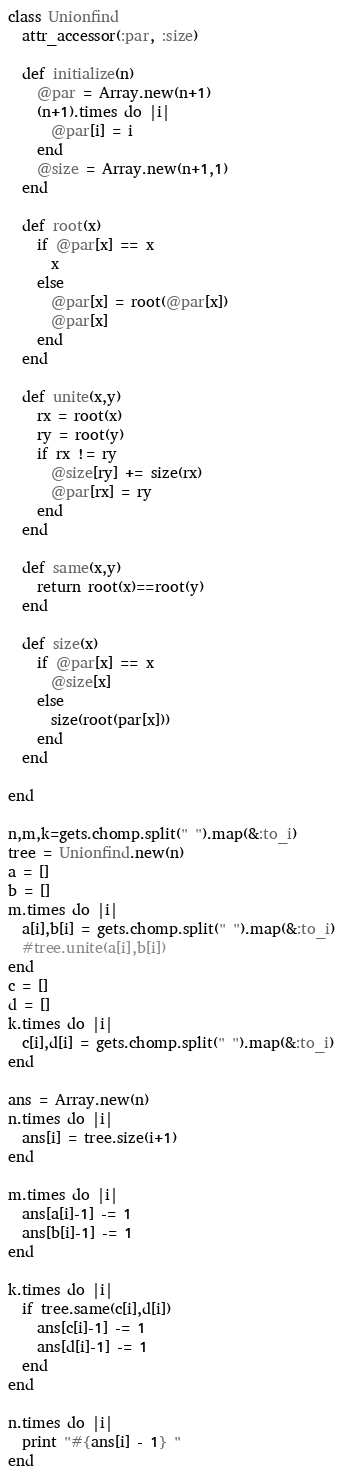Convert code to text. <code><loc_0><loc_0><loc_500><loc_500><_Ruby_>class Unionfind
  attr_accessor(:par, :size)

  def initialize(n)
    @par = Array.new(n+1)
    (n+1).times do |i|
      @par[i] = i
    end
    @size = Array.new(n+1,1)
  end

  def root(x)
    if @par[x] == x
      x
    else
      @par[x] = root(@par[x])
      @par[x]
    end
  end

  def unite(x,y)
    rx = root(x)
    ry = root(y)
    if rx != ry
      @size[ry] += size(rx)
      @par[rx] = ry
    end
  end

  def same(x,y)
    return root(x)==root(y)
  end

  def size(x)
    if @par[x] == x
      @size[x]
    else
      size(root(par[x]))
    end
  end

end

n,m,k=gets.chomp.split(" ").map(&:to_i)
tree = Unionfind.new(n)
a = []
b = []
m.times do |i|
  a[i],b[i] = gets.chomp.split(" ").map(&:to_i)
  #tree.unite(a[i],b[i])
end
c = []
d = []
k.times do |i|
  c[i],d[i] = gets.chomp.split(" ").map(&:to_i)
end

ans = Array.new(n)
n.times do |i|
  ans[i] = tree.size(i+1)
end

m.times do |i|
  ans[a[i]-1] -= 1
  ans[b[i]-1] -= 1
end

k.times do |i|
  if tree.same(c[i],d[i])
    ans[c[i]-1] -= 1
    ans[d[i]-1] -= 1
  end
end

n.times do |i|
  print "#{ans[i] - 1} "
end</code> 